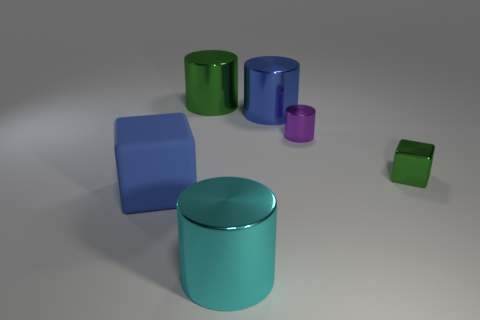What shape is the green object left of the big shiny cylinder in front of the matte block?
Keep it short and to the point. Cylinder. There is a large blue thing that is the same shape as the tiny green metallic object; what is it made of?
Keep it short and to the point. Rubber. There is a matte thing that is the same size as the cyan cylinder; what is its color?
Your answer should be compact. Blue. Are there the same number of cyan cylinders that are behind the blue cube and big red cylinders?
Ensure brevity in your answer.  Yes. There is a object that is to the left of the big metallic cylinder that is behind the blue metal cylinder; what is its color?
Offer a terse response. Blue. There is a block that is right of the metallic cylinder that is in front of the blue rubber block; what is its size?
Make the answer very short. Small. What is the size of the thing that is the same color as the metallic cube?
Your answer should be very brief. Large. What number of other objects are there of the same size as the blue cube?
Your response must be concise. 3. There is a big metallic object that is behind the blue thing on the right side of the metallic cylinder that is in front of the large cube; what is its color?
Keep it short and to the point. Green. How many other things are the same shape as the blue matte thing?
Your answer should be very brief. 1. 